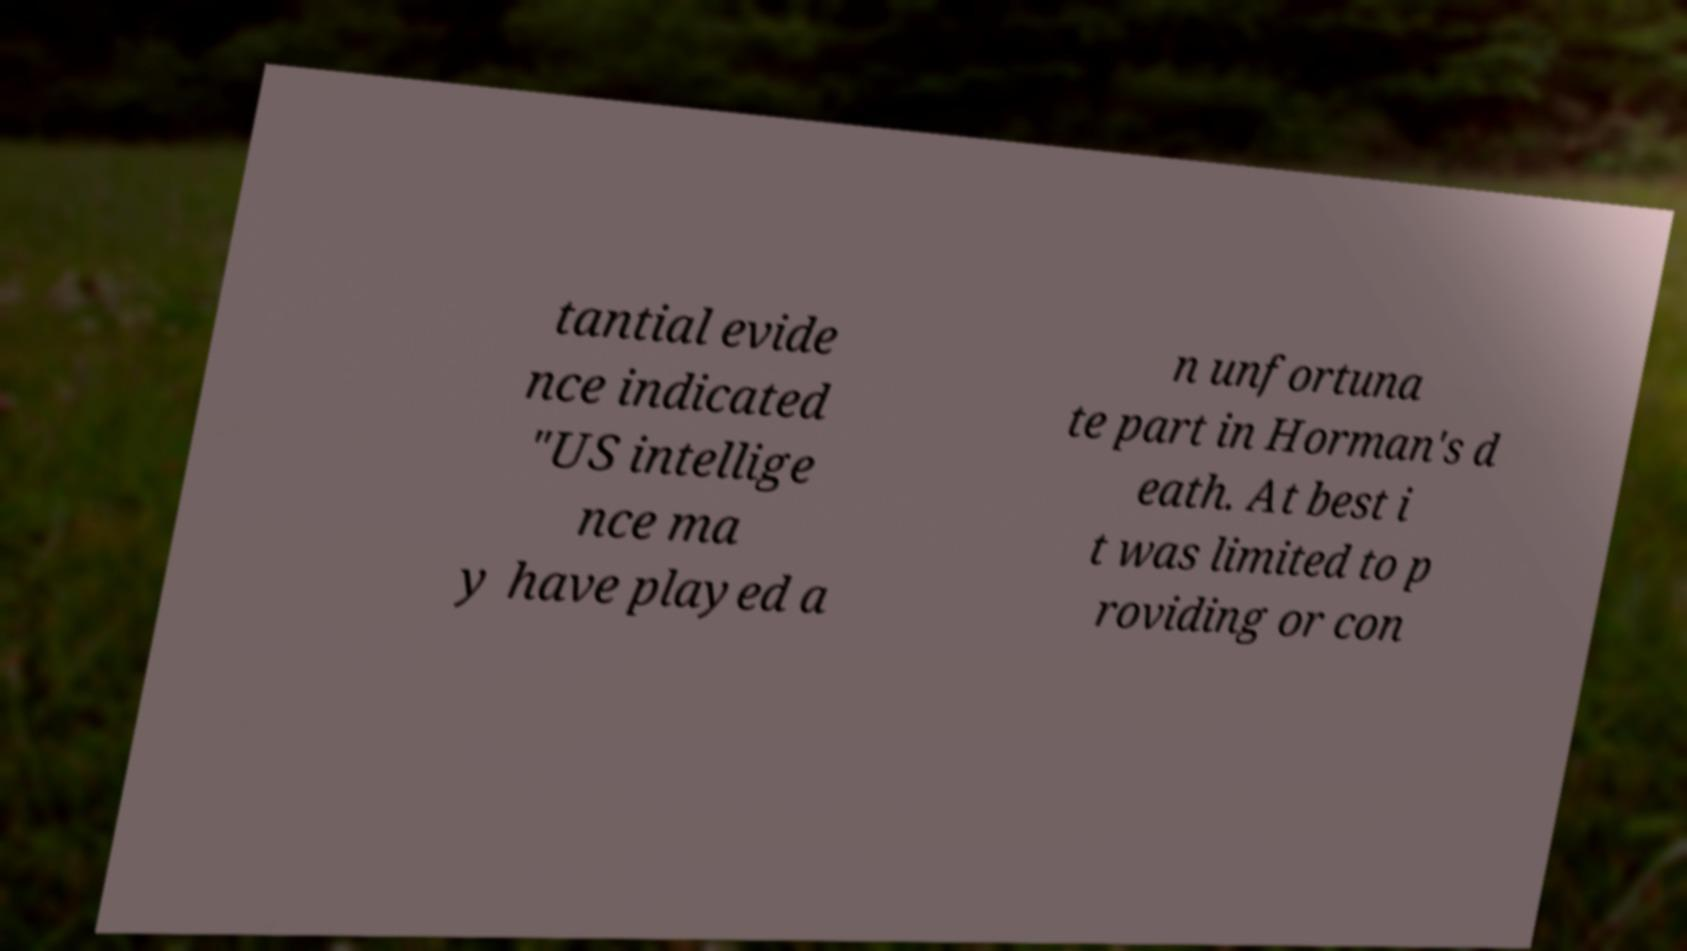I need the written content from this picture converted into text. Can you do that? tantial evide nce indicated "US intellige nce ma y have played a n unfortuna te part in Horman's d eath. At best i t was limited to p roviding or con 